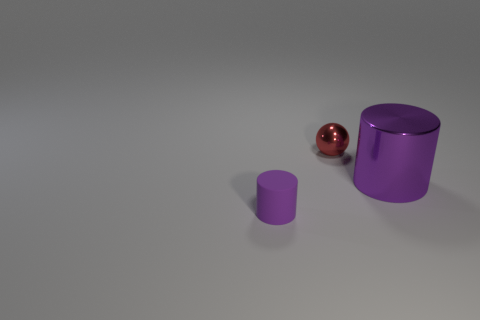Add 1 small purple objects. How many objects exist? 4 Subtract all cylinders. How many objects are left? 1 Add 3 tiny red metallic things. How many tiny red metallic things exist? 4 Subtract 0 gray blocks. How many objects are left? 3 Subtract all purple metallic cubes. Subtract all large cylinders. How many objects are left? 2 Add 2 big purple things. How many big purple things are left? 3 